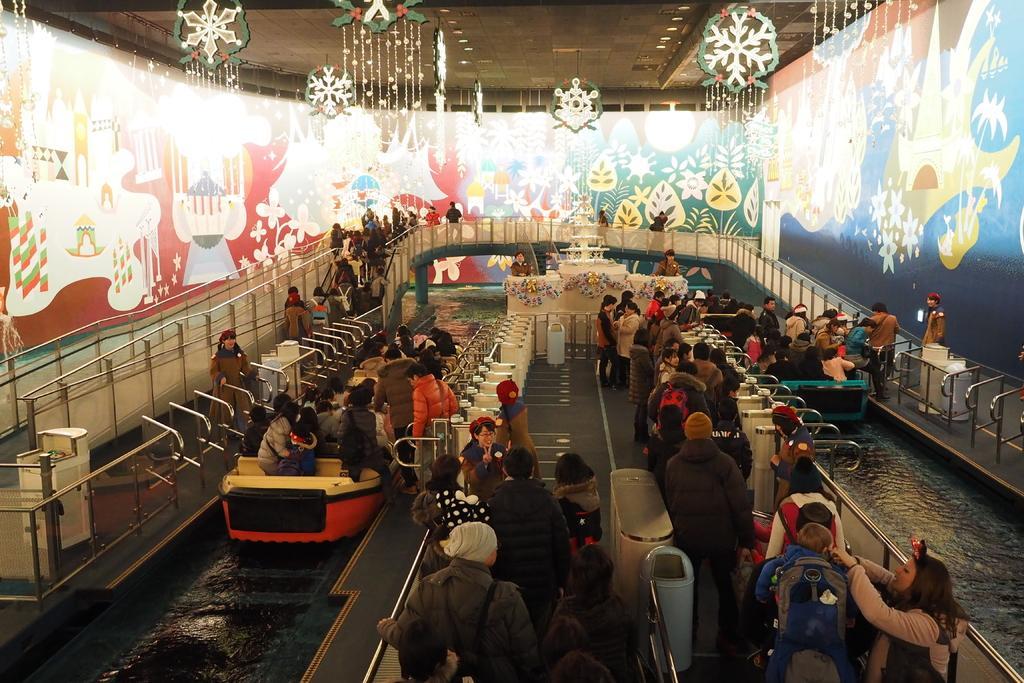Describe this image in one or two sentences. In this image we can see water rides. At the center of the image there are people standing. In the background of the image there are painting on the wall. There is a railing. On top of the image there is a ceiling with lights. 